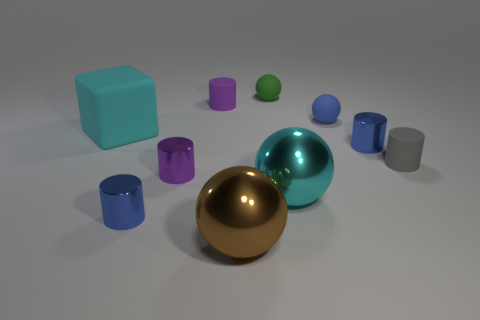Subtract all gray cylinders. How many cylinders are left? 4 Subtract all gray cylinders. How many cylinders are left? 4 Subtract all yellow cylinders. Subtract all yellow balls. How many cylinders are left? 5 Subtract all balls. How many objects are left? 6 Subtract all cyan balls. Subtract all tiny gray cylinders. How many objects are left? 8 Add 2 small purple shiny objects. How many small purple shiny objects are left? 3 Add 3 blue rubber blocks. How many blue rubber blocks exist? 3 Subtract 0 brown cubes. How many objects are left? 10 